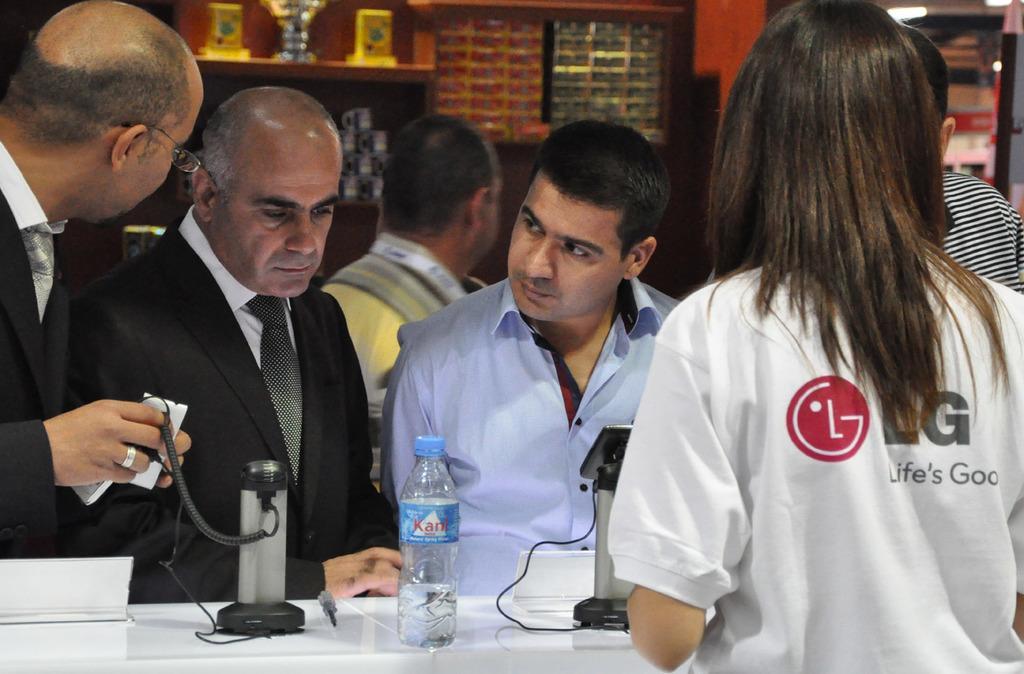How would you summarize this image in a sentence or two? In this picture we can observe some people standing in front of a desk on which a mobile and water bottles are placed. We can observe two men are wearing coats. There is a woman on the right side. In the background we can observe some people standing. 